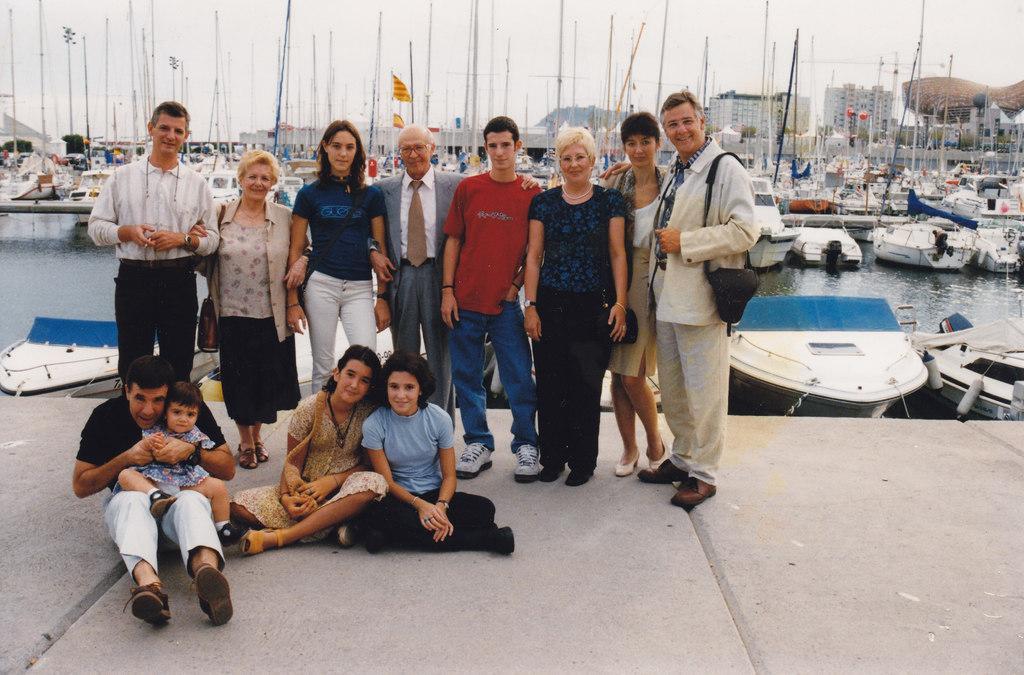Could you give a brief overview of what you see in this image? In this picture there are group of people standing and there are group of people sitting. At the back there are boats on the water and there are buildings, trees. At the top there is sky. At the bottom there is water. 